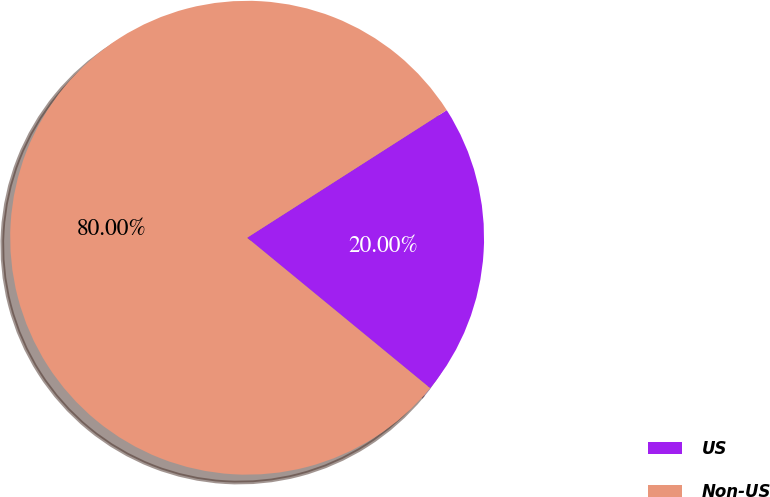Convert chart to OTSL. <chart><loc_0><loc_0><loc_500><loc_500><pie_chart><fcel>US<fcel>Non-US<nl><fcel>20.0%<fcel>80.0%<nl></chart> 